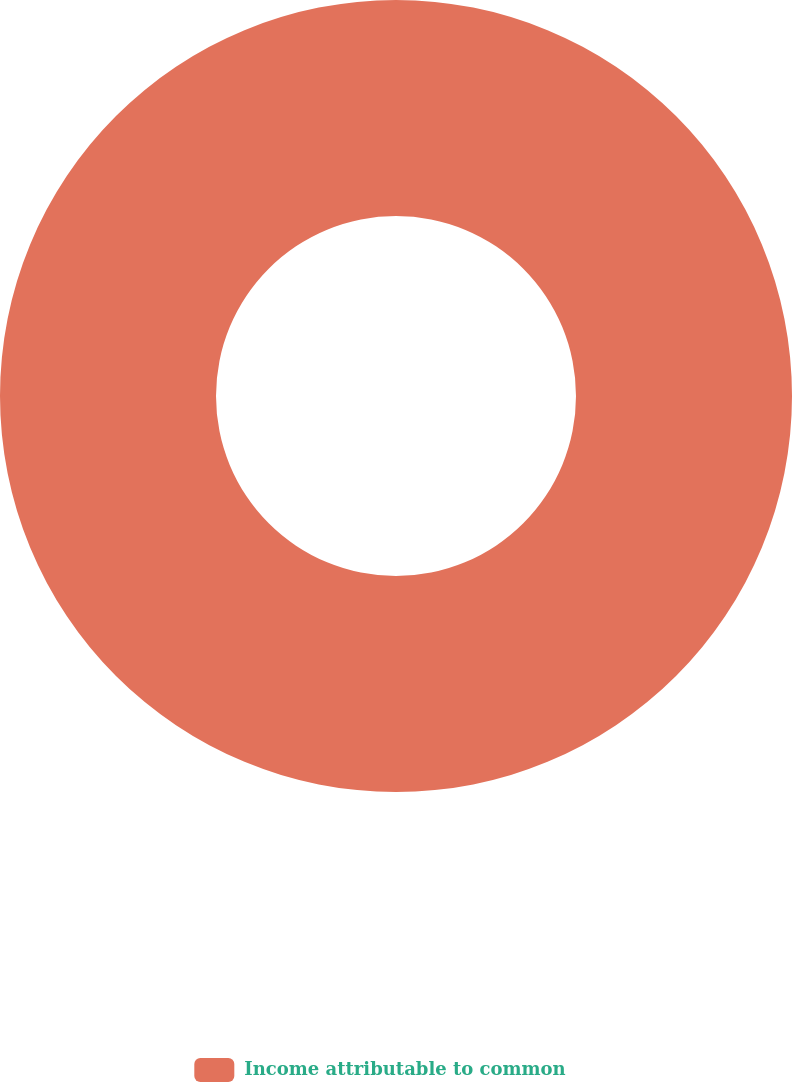Convert chart to OTSL. <chart><loc_0><loc_0><loc_500><loc_500><pie_chart><fcel>Income attributable to common<nl><fcel>100.0%<nl></chart> 